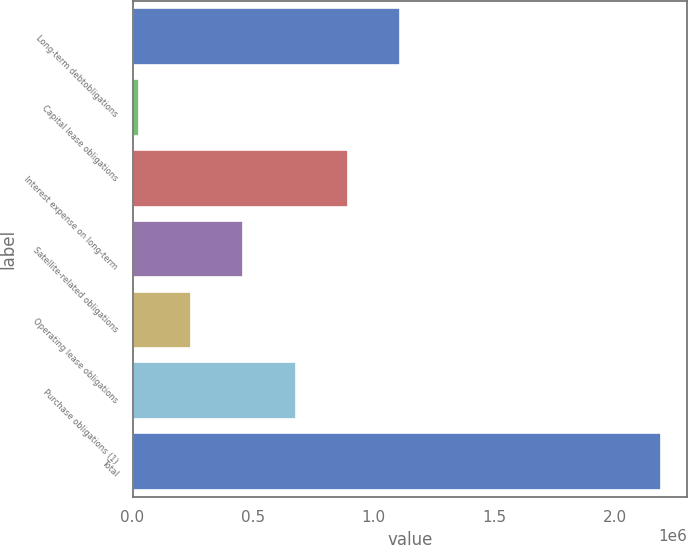<chart> <loc_0><loc_0><loc_500><loc_500><bar_chart><fcel>Long-term debtobligations<fcel>Capital lease obligations<fcel>Interest expense on long-term<fcel>Satellite-related obligations<fcel>Operating lease obligations<fcel>Purchase obligations (1)<fcel>Total<nl><fcel>1.10859e+06<fcel>27339<fcel>892338<fcel>459838<fcel>243589<fcel>676088<fcel>2.18984e+06<nl></chart> 